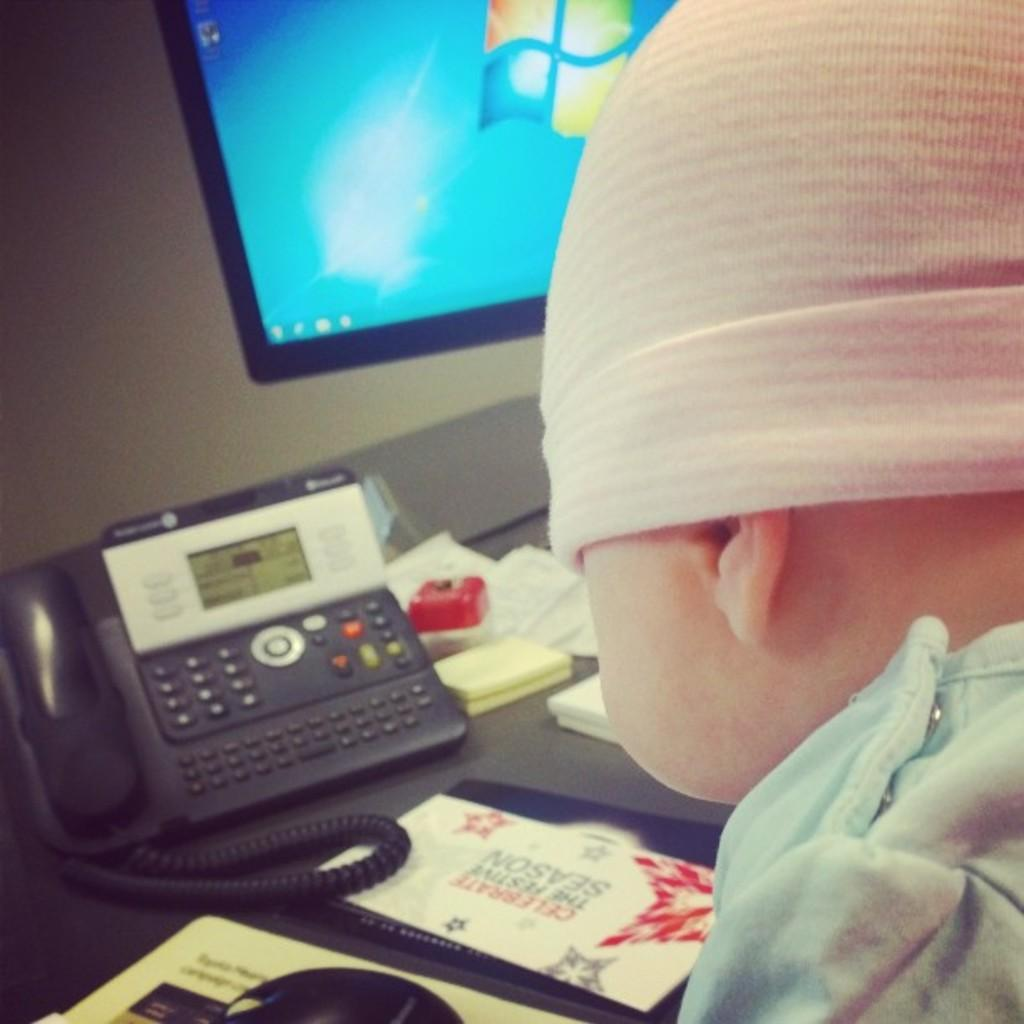What is the main subject of the image? There is a kid in the image. Where is the kid located in relation to the table? The kid is in front of a table. What objects are on the table? There is a telephone and a book on the table. What type of device is visible in the image? There is a screen visible in the image. What type of stocking is the kid wearing on their neck in the image? There is no stocking visible on the kid's neck in the image. Can you describe the swing that the kid is using in the image? There is no swing present in the image; the kid is in front of a table. 